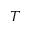<formula> <loc_0><loc_0><loc_500><loc_500>T</formula> 